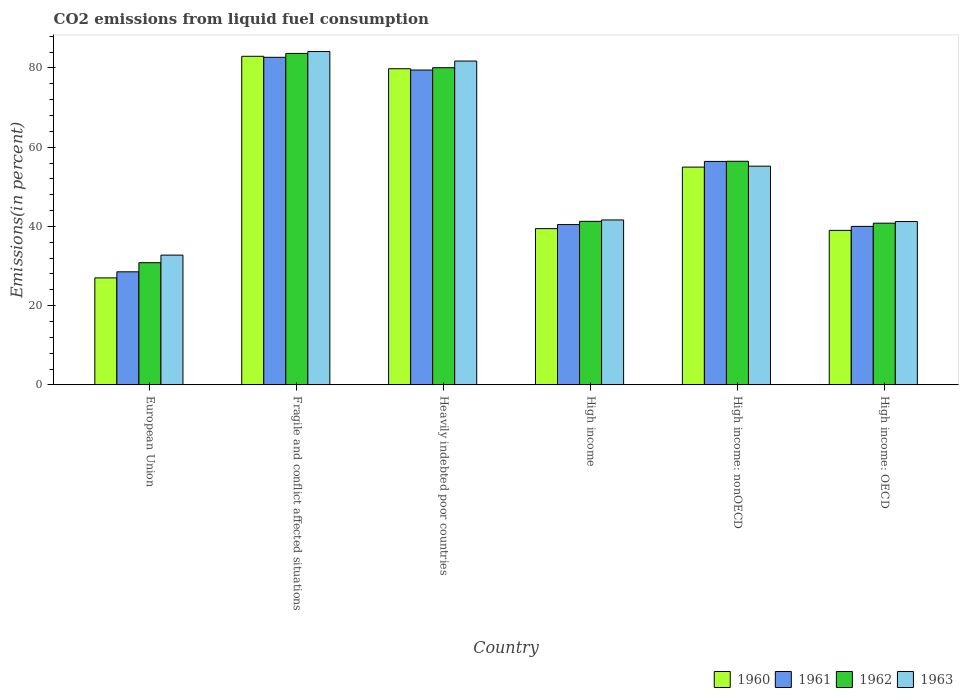How many groups of bars are there?
Give a very brief answer. 6. Are the number of bars per tick equal to the number of legend labels?
Keep it short and to the point. Yes. How many bars are there on the 1st tick from the left?
Provide a succinct answer. 4. How many bars are there on the 1st tick from the right?
Make the answer very short. 4. What is the label of the 1st group of bars from the left?
Ensure brevity in your answer.  European Union. What is the total CO2 emitted in 1961 in Fragile and conflict affected situations?
Provide a short and direct response. 82.67. Across all countries, what is the maximum total CO2 emitted in 1960?
Offer a terse response. 82.93. Across all countries, what is the minimum total CO2 emitted in 1961?
Offer a terse response. 28.54. In which country was the total CO2 emitted in 1961 maximum?
Provide a succinct answer. Fragile and conflict affected situations. In which country was the total CO2 emitted in 1960 minimum?
Offer a terse response. European Union. What is the total total CO2 emitted in 1960 in the graph?
Your answer should be very brief. 323.12. What is the difference between the total CO2 emitted in 1961 in European Union and that in Fragile and conflict affected situations?
Your answer should be very brief. -54.12. What is the difference between the total CO2 emitted in 1963 in Heavily indebted poor countries and the total CO2 emitted in 1961 in European Union?
Your answer should be compact. 53.19. What is the average total CO2 emitted in 1963 per country?
Keep it short and to the point. 56.11. What is the difference between the total CO2 emitted of/in 1962 and total CO2 emitted of/in 1961 in Fragile and conflict affected situations?
Your answer should be compact. 0.98. In how many countries, is the total CO2 emitted in 1963 greater than 16 %?
Provide a short and direct response. 6. What is the ratio of the total CO2 emitted in 1963 in Fragile and conflict affected situations to that in Heavily indebted poor countries?
Your response must be concise. 1.03. Is the total CO2 emitted in 1963 in High income: OECD less than that in High income: nonOECD?
Provide a succinct answer. Yes. Is the difference between the total CO2 emitted in 1962 in European Union and High income: OECD greater than the difference between the total CO2 emitted in 1961 in European Union and High income: OECD?
Make the answer very short. Yes. What is the difference between the highest and the second highest total CO2 emitted in 1961?
Ensure brevity in your answer.  -26.27. What is the difference between the highest and the lowest total CO2 emitted in 1960?
Keep it short and to the point. 55.92. Is the sum of the total CO2 emitted in 1962 in Heavily indebted poor countries and High income greater than the maximum total CO2 emitted in 1963 across all countries?
Provide a short and direct response. Yes. What does the 4th bar from the left in High income represents?
Provide a succinct answer. 1963. Is it the case that in every country, the sum of the total CO2 emitted in 1960 and total CO2 emitted in 1961 is greater than the total CO2 emitted in 1962?
Provide a short and direct response. Yes. Are the values on the major ticks of Y-axis written in scientific E-notation?
Provide a short and direct response. No. Does the graph contain any zero values?
Give a very brief answer. No. Does the graph contain grids?
Give a very brief answer. No. How are the legend labels stacked?
Ensure brevity in your answer.  Horizontal. What is the title of the graph?
Give a very brief answer. CO2 emissions from liquid fuel consumption. Does "1996" appear as one of the legend labels in the graph?
Give a very brief answer. No. What is the label or title of the Y-axis?
Provide a short and direct response. Emissions(in percent). What is the Emissions(in percent) in 1960 in European Union?
Your answer should be very brief. 27.01. What is the Emissions(in percent) in 1961 in European Union?
Provide a succinct answer. 28.54. What is the Emissions(in percent) of 1962 in European Union?
Your answer should be very brief. 30.84. What is the Emissions(in percent) of 1963 in European Union?
Your answer should be compact. 32.75. What is the Emissions(in percent) in 1960 in Fragile and conflict affected situations?
Your answer should be very brief. 82.93. What is the Emissions(in percent) of 1961 in Fragile and conflict affected situations?
Offer a very short reply. 82.67. What is the Emissions(in percent) in 1962 in Fragile and conflict affected situations?
Offer a terse response. 83.65. What is the Emissions(in percent) in 1963 in Fragile and conflict affected situations?
Your response must be concise. 84.13. What is the Emissions(in percent) in 1960 in Heavily indebted poor countries?
Your response must be concise. 79.79. What is the Emissions(in percent) of 1961 in Heavily indebted poor countries?
Your answer should be very brief. 79.46. What is the Emissions(in percent) in 1962 in Heavily indebted poor countries?
Ensure brevity in your answer.  80.05. What is the Emissions(in percent) in 1963 in Heavily indebted poor countries?
Your answer should be compact. 81.73. What is the Emissions(in percent) of 1960 in High income?
Your answer should be compact. 39.44. What is the Emissions(in percent) of 1961 in High income?
Your answer should be very brief. 40.46. What is the Emissions(in percent) in 1962 in High income?
Provide a short and direct response. 41.28. What is the Emissions(in percent) of 1963 in High income?
Your response must be concise. 41.63. What is the Emissions(in percent) of 1960 in High income: nonOECD?
Your answer should be very brief. 54.97. What is the Emissions(in percent) in 1961 in High income: nonOECD?
Make the answer very short. 56.4. What is the Emissions(in percent) in 1962 in High income: nonOECD?
Your response must be concise. 56.43. What is the Emissions(in percent) of 1963 in High income: nonOECD?
Your answer should be compact. 55.2. What is the Emissions(in percent) in 1960 in High income: OECD?
Make the answer very short. 39. What is the Emissions(in percent) in 1961 in High income: OECD?
Your answer should be very brief. 40. What is the Emissions(in percent) of 1962 in High income: OECD?
Offer a terse response. 40.81. What is the Emissions(in percent) in 1963 in High income: OECD?
Offer a very short reply. 41.23. Across all countries, what is the maximum Emissions(in percent) of 1960?
Your answer should be compact. 82.93. Across all countries, what is the maximum Emissions(in percent) in 1961?
Give a very brief answer. 82.67. Across all countries, what is the maximum Emissions(in percent) in 1962?
Give a very brief answer. 83.65. Across all countries, what is the maximum Emissions(in percent) in 1963?
Your answer should be very brief. 84.13. Across all countries, what is the minimum Emissions(in percent) of 1960?
Your answer should be compact. 27.01. Across all countries, what is the minimum Emissions(in percent) in 1961?
Provide a short and direct response. 28.54. Across all countries, what is the minimum Emissions(in percent) of 1962?
Ensure brevity in your answer.  30.84. Across all countries, what is the minimum Emissions(in percent) of 1963?
Offer a terse response. 32.75. What is the total Emissions(in percent) of 1960 in the graph?
Offer a very short reply. 323.12. What is the total Emissions(in percent) of 1961 in the graph?
Provide a short and direct response. 327.54. What is the total Emissions(in percent) of 1962 in the graph?
Give a very brief answer. 333.07. What is the total Emissions(in percent) of 1963 in the graph?
Provide a short and direct response. 336.67. What is the difference between the Emissions(in percent) in 1960 in European Union and that in Fragile and conflict affected situations?
Offer a terse response. -55.92. What is the difference between the Emissions(in percent) of 1961 in European Union and that in Fragile and conflict affected situations?
Ensure brevity in your answer.  -54.12. What is the difference between the Emissions(in percent) in 1962 in European Union and that in Fragile and conflict affected situations?
Keep it short and to the point. -52.81. What is the difference between the Emissions(in percent) in 1963 in European Union and that in Fragile and conflict affected situations?
Your response must be concise. -51.37. What is the difference between the Emissions(in percent) in 1960 in European Union and that in Heavily indebted poor countries?
Ensure brevity in your answer.  -52.78. What is the difference between the Emissions(in percent) in 1961 in European Union and that in Heavily indebted poor countries?
Offer a terse response. -50.91. What is the difference between the Emissions(in percent) in 1962 in European Union and that in Heavily indebted poor countries?
Your response must be concise. -49.21. What is the difference between the Emissions(in percent) of 1963 in European Union and that in Heavily indebted poor countries?
Provide a short and direct response. -48.98. What is the difference between the Emissions(in percent) in 1960 in European Union and that in High income?
Provide a succinct answer. -12.43. What is the difference between the Emissions(in percent) in 1961 in European Union and that in High income?
Provide a short and direct response. -11.92. What is the difference between the Emissions(in percent) in 1962 in European Union and that in High income?
Your answer should be compact. -10.44. What is the difference between the Emissions(in percent) in 1963 in European Union and that in High income?
Give a very brief answer. -8.87. What is the difference between the Emissions(in percent) in 1960 in European Union and that in High income: nonOECD?
Provide a succinct answer. -27.96. What is the difference between the Emissions(in percent) in 1961 in European Union and that in High income: nonOECD?
Give a very brief answer. -27.86. What is the difference between the Emissions(in percent) of 1962 in European Union and that in High income: nonOECD?
Keep it short and to the point. -25.59. What is the difference between the Emissions(in percent) of 1963 in European Union and that in High income: nonOECD?
Keep it short and to the point. -22.45. What is the difference between the Emissions(in percent) in 1960 in European Union and that in High income: OECD?
Ensure brevity in your answer.  -11.99. What is the difference between the Emissions(in percent) of 1961 in European Union and that in High income: OECD?
Offer a terse response. -11.46. What is the difference between the Emissions(in percent) in 1962 in European Union and that in High income: OECD?
Your answer should be compact. -9.97. What is the difference between the Emissions(in percent) of 1963 in European Union and that in High income: OECD?
Your answer should be compact. -8.47. What is the difference between the Emissions(in percent) in 1960 in Fragile and conflict affected situations and that in Heavily indebted poor countries?
Offer a very short reply. 3.14. What is the difference between the Emissions(in percent) in 1961 in Fragile and conflict affected situations and that in Heavily indebted poor countries?
Offer a very short reply. 3.21. What is the difference between the Emissions(in percent) of 1962 in Fragile and conflict affected situations and that in Heavily indebted poor countries?
Keep it short and to the point. 3.6. What is the difference between the Emissions(in percent) in 1963 in Fragile and conflict affected situations and that in Heavily indebted poor countries?
Your response must be concise. 2.4. What is the difference between the Emissions(in percent) in 1960 in Fragile and conflict affected situations and that in High income?
Your answer should be very brief. 43.49. What is the difference between the Emissions(in percent) in 1961 in Fragile and conflict affected situations and that in High income?
Offer a very short reply. 42.21. What is the difference between the Emissions(in percent) of 1962 in Fragile and conflict affected situations and that in High income?
Provide a short and direct response. 42.37. What is the difference between the Emissions(in percent) in 1963 in Fragile and conflict affected situations and that in High income?
Provide a succinct answer. 42.5. What is the difference between the Emissions(in percent) of 1960 in Fragile and conflict affected situations and that in High income: nonOECD?
Keep it short and to the point. 27.96. What is the difference between the Emissions(in percent) in 1961 in Fragile and conflict affected situations and that in High income: nonOECD?
Your answer should be very brief. 26.27. What is the difference between the Emissions(in percent) of 1962 in Fragile and conflict affected situations and that in High income: nonOECD?
Offer a terse response. 27.22. What is the difference between the Emissions(in percent) in 1963 in Fragile and conflict affected situations and that in High income: nonOECD?
Your response must be concise. 28.92. What is the difference between the Emissions(in percent) in 1960 in Fragile and conflict affected situations and that in High income: OECD?
Your response must be concise. 43.93. What is the difference between the Emissions(in percent) of 1961 in Fragile and conflict affected situations and that in High income: OECD?
Provide a short and direct response. 42.66. What is the difference between the Emissions(in percent) of 1962 in Fragile and conflict affected situations and that in High income: OECD?
Make the answer very short. 42.84. What is the difference between the Emissions(in percent) in 1963 in Fragile and conflict affected situations and that in High income: OECD?
Make the answer very short. 42.9. What is the difference between the Emissions(in percent) of 1960 in Heavily indebted poor countries and that in High income?
Your answer should be compact. 40.35. What is the difference between the Emissions(in percent) of 1961 in Heavily indebted poor countries and that in High income?
Provide a succinct answer. 38.99. What is the difference between the Emissions(in percent) in 1962 in Heavily indebted poor countries and that in High income?
Your answer should be very brief. 38.77. What is the difference between the Emissions(in percent) in 1963 in Heavily indebted poor countries and that in High income?
Make the answer very short. 40.1. What is the difference between the Emissions(in percent) of 1960 in Heavily indebted poor countries and that in High income: nonOECD?
Your answer should be compact. 24.82. What is the difference between the Emissions(in percent) in 1961 in Heavily indebted poor countries and that in High income: nonOECD?
Offer a terse response. 23.06. What is the difference between the Emissions(in percent) of 1962 in Heavily indebted poor countries and that in High income: nonOECD?
Give a very brief answer. 23.62. What is the difference between the Emissions(in percent) in 1963 in Heavily indebted poor countries and that in High income: nonOECD?
Give a very brief answer. 26.53. What is the difference between the Emissions(in percent) in 1960 in Heavily indebted poor countries and that in High income: OECD?
Provide a short and direct response. 40.79. What is the difference between the Emissions(in percent) of 1961 in Heavily indebted poor countries and that in High income: OECD?
Provide a short and direct response. 39.45. What is the difference between the Emissions(in percent) in 1962 in Heavily indebted poor countries and that in High income: OECD?
Your answer should be very brief. 39.24. What is the difference between the Emissions(in percent) in 1963 in Heavily indebted poor countries and that in High income: OECD?
Provide a succinct answer. 40.51. What is the difference between the Emissions(in percent) in 1960 in High income and that in High income: nonOECD?
Give a very brief answer. -15.53. What is the difference between the Emissions(in percent) in 1961 in High income and that in High income: nonOECD?
Your response must be concise. -15.94. What is the difference between the Emissions(in percent) in 1962 in High income and that in High income: nonOECD?
Keep it short and to the point. -15.16. What is the difference between the Emissions(in percent) in 1963 in High income and that in High income: nonOECD?
Offer a very short reply. -13.57. What is the difference between the Emissions(in percent) of 1960 in High income and that in High income: OECD?
Your answer should be very brief. 0.44. What is the difference between the Emissions(in percent) of 1961 in High income and that in High income: OECD?
Keep it short and to the point. 0.46. What is the difference between the Emissions(in percent) in 1962 in High income and that in High income: OECD?
Offer a very short reply. 0.47. What is the difference between the Emissions(in percent) in 1963 in High income and that in High income: OECD?
Keep it short and to the point. 0.4. What is the difference between the Emissions(in percent) of 1960 in High income: nonOECD and that in High income: OECD?
Your answer should be very brief. 15.97. What is the difference between the Emissions(in percent) of 1961 in High income: nonOECD and that in High income: OECD?
Give a very brief answer. 16.4. What is the difference between the Emissions(in percent) in 1962 in High income: nonOECD and that in High income: OECD?
Offer a terse response. 15.62. What is the difference between the Emissions(in percent) of 1963 in High income: nonOECD and that in High income: OECD?
Ensure brevity in your answer.  13.98. What is the difference between the Emissions(in percent) of 1960 in European Union and the Emissions(in percent) of 1961 in Fragile and conflict affected situations?
Ensure brevity in your answer.  -55.66. What is the difference between the Emissions(in percent) in 1960 in European Union and the Emissions(in percent) in 1962 in Fragile and conflict affected situations?
Your answer should be compact. -56.64. What is the difference between the Emissions(in percent) of 1960 in European Union and the Emissions(in percent) of 1963 in Fragile and conflict affected situations?
Provide a short and direct response. -57.12. What is the difference between the Emissions(in percent) of 1961 in European Union and the Emissions(in percent) of 1962 in Fragile and conflict affected situations?
Your answer should be very brief. -55.11. What is the difference between the Emissions(in percent) in 1961 in European Union and the Emissions(in percent) in 1963 in Fragile and conflict affected situations?
Ensure brevity in your answer.  -55.58. What is the difference between the Emissions(in percent) of 1962 in European Union and the Emissions(in percent) of 1963 in Fragile and conflict affected situations?
Your answer should be compact. -53.29. What is the difference between the Emissions(in percent) in 1960 in European Union and the Emissions(in percent) in 1961 in Heavily indebted poor countries?
Offer a very short reply. -52.45. What is the difference between the Emissions(in percent) of 1960 in European Union and the Emissions(in percent) of 1962 in Heavily indebted poor countries?
Give a very brief answer. -53.04. What is the difference between the Emissions(in percent) of 1960 in European Union and the Emissions(in percent) of 1963 in Heavily indebted poor countries?
Provide a succinct answer. -54.72. What is the difference between the Emissions(in percent) of 1961 in European Union and the Emissions(in percent) of 1962 in Heavily indebted poor countries?
Keep it short and to the point. -51.51. What is the difference between the Emissions(in percent) of 1961 in European Union and the Emissions(in percent) of 1963 in Heavily indebted poor countries?
Your answer should be compact. -53.19. What is the difference between the Emissions(in percent) of 1962 in European Union and the Emissions(in percent) of 1963 in Heavily indebted poor countries?
Your answer should be compact. -50.89. What is the difference between the Emissions(in percent) in 1960 in European Union and the Emissions(in percent) in 1961 in High income?
Ensure brevity in your answer.  -13.46. What is the difference between the Emissions(in percent) in 1960 in European Union and the Emissions(in percent) in 1962 in High income?
Provide a succinct answer. -14.27. What is the difference between the Emissions(in percent) of 1960 in European Union and the Emissions(in percent) of 1963 in High income?
Provide a succinct answer. -14.62. What is the difference between the Emissions(in percent) of 1961 in European Union and the Emissions(in percent) of 1962 in High income?
Make the answer very short. -12.73. What is the difference between the Emissions(in percent) of 1961 in European Union and the Emissions(in percent) of 1963 in High income?
Your answer should be compact. -13.08. What is the difference between the Emissions(in percent) in 1962 in European Union and the Emissions(in percent) in 1963 in High income?
Your response must be concise. -10.79. What is the difference between the Emissions(in percent) of 1960 in European Union and the Emissions(in percent) of 1961 in High income: nonOECD?
Give a very brief answer. -29.39. What is the difference between the Emissions(in percent) of 1960 in European Union and the Emissions(in percent) of 1962 in High income: nonOECD?
Keep it short and to the point. -29.43. What is the difference between the Emissions(in percent) in 1960 in European Union and the Emissions(in percent) in 1963 in High income: nonOECD?
Give a very brief answer. -28.19. What is the difference between the Emissions(in percent) in 1961 in European Union and the Emissions(in percent) in 1962 in High income: nonOECD?
Keep it short and to the point. -27.89. What is the difference between the Emissions(in percent) in 1961 in European Union and the Emissions(in percent) in 1963 in High income: nonOECD?
Your answer should be compact. -26.66. What is the difference between the Emissions(in percent) of 1962 in European Union and the Emissions(in percent) of 1963 in High income: nonOECD?
Give a very brief answer. -24.36. What is the difference between the Emissions(in percent) in 1960 in European Union and the Emissions(in percent) in 1961 in High income: OECD?
Keep it short and to the point. -13. What is the difference between the Emissions(in percent) of 1960 in European Union and the Emissions(in percent) of 1962 in High income: OECD?
Offer a very short reply. -13.81. What is the difference between the Emissions(in percent) of 1960 in European Union and the Emissions(in percent) of 1963 in High income: OECD?
Offer a very short reply. -14.22. What is the difference between the Emissions(in percent) of 1961 in European Union and the Emissions(in percent) of 1962 in High income: OECD?
Offer a terse response. -12.27. What is the difference between the Emissions(in percent) of 1961 in European Union and the Emissions(in percent) of 1963 in High income: OECD?
Your answer should be very brief. -12.68. What is the difference between the Emissions(in percent) of 1962 in European Union and the Emissions(in percent) of 1963 in High income: OECD?
Your answer should be very brief. -10.39. What is the difference between the Emissions(in percent) of 1960 in Fragile and conflict affected situations and the Emissions(in percent) of 1961 in Heavily indebted poor countries?
Provide a succinct answer. 3.47. What is the difference between the Emissions(in percent) of 1960 in Fragile and conflict affected situations and the Emissions(in percent) of 1962 in Heavily indebted poor countries?
Your answer should be very brief. 2.88. What is the difference between the Emissions(in percent) in 1960 in Fragile and conflict affected situations and the Emissions(in percent) in 1963 in Heavily indebted poor countries?
Your answer should be compact. 1.2. What is the difference between the Emissions(in percent) in 1961 in Fragile and conflict affected situations and the Emissions(in percent) in 1962 in Heavily indebted poor countries?
Ensure brevity in your answer.  2.62. What is the difference between the Emissions(in percent) in 1961 in Fragile and conflict affected situations and the Emissions(in percent) in 1963 in Heavily indebted poor countries?
Provide a succinct answer. 0.94. What is the difference between the Emissions(in percent) of 1962 in Fragile and conflict affected situations and the Emissions(in percent) of 1963 in Heavily indebted poor countries?
Offer a very short reply. 1.92. What is the difference between the Emissions(in percent) of 1960 in Fragile and conflict affected situations and the Emissions(in percent) of 1961 in High income?
Provide a short and direct response. 42.47. What is the difference between the Emissions(in percent) of 1960 in Fragile and conflict affected situations and the Emissions(in percent) of 1962 in High income?
Offer a very short reply. 41.65. What is the difference between the Emissions(in percent) in 1960 in Fragile and conflict affected situations and the Emissions(in percent) in 1963 in High income?
Offer a terse response. 41.3. What is the difference between the Emissions(in percent) in 1961 in Fragile and conflict affected situations and the Emissions(in percent) in 1962 in High income?
Give a very brief answer. 41.39. What is the difference between the Emissions(in percent) of 1961 in Fragile and conflict affected situations and the Emissions(in percent) of 1963 in High income?
Offer a terse response. 41.04. What is the difference between the Emissions(in percent) of 1962 in Fragile and conflict affected situations and the Emissions(in percent) of 1963 in High income?
Offer a terse response. 42.02. What is the difference between the Emissions(in percent) of 1960 in Fragile and conflict affected situations and the Emissions(in percent) of 1961 in High income: nonOECD?
Keep it short and to the point. 26.53. What is the difference between the Emissions(in percent) in 1960 in Fragile and conflict affected situations and the Emissions(in percent) in 1962 in High income: nonOECD?
Your response must be concise. 26.5. What is the difference between the Emissions(in percent) of 1960 in Fragile and conflict affected situations and the Emissions(in percent) of 1963 in High income: nonOECD?
Provide a short and direct response. 27.73. What is the difference between the Emissions(in percent) of 1961 in Fragile and conflict affected situations and the Emissions(in percent) of 1962 in High income: nonOECD?
Your answer should be very brief. 26.23. What is the difference between the Emissions(in percent) of 1961 in Fragile and conflict affected situations and the Emissions(in percent) of 1963 in High income: nonOECD?
Your response must be concise. 27.47. What is the difference between the Emissions(in percent) of 1962 in Fragile and conflict affected situations and the Emissions(in percent) of 1963 in High income: nonOECD?
Offer a terse response. 28.45. What is the difference between the Emissions(in percent) in 1960 in Fragile and conflict affected situations and the Emissions(in percent) in 1961 in High income: OECD?
Provide a short and direct response. 42.93. What is the difference between the Emissions(in percent) in 1960 in Fragile and conflict affected situations and the Emissions(in percent) in 1962 in High income: OECD?
Your answer should be very brief. 42.12. What is the difference between the Emissions(in percent) of 1960 in Fragile and conflict affected situations and the Emissions(in percent) of 1963 in High income: OECD?
Provide a short and direct response. 41.7. What is the difference between the Emissions(in percent) of 1961 in Fragile and conflict affected situations and the Emissions(in percent) of 1962 in High income: OECD?
Give a very brief answer. 41.86. What is the difference between the Emissions(in percent) of 1961 in Fragile and conflict affected situations and the Emissions(in percent) of 1963 in High income: OECD?
Your response must be concise. 41.44. What is the difference between the Emissions(in percent) of 1962 in Fragile and conflict affected situations and the Emissions(in percent) of 1963 in High income: OECD?
Keep it short and to the point. 42.43. What is the difference between the Emissions(in percent) in 1960 in Heavily indebted poor countries and the Emissions(in percent) in 1961 in High income?
Make the answer very short. 39.32. What is the difference between the Emissions(in percent) of 1960 in Heavily indebted poor countries and the Emissions(in percent) of 1962 in High income?
Give a very brief answer. 38.51. What is the difference between the Emissions(in percent) in 1960 in Heavily indebted poor countries and the Emissions(in percent) in 1963 in High income?
Keep it short and to the point. 38.16. What is the difference between the Emissions(in percent) of 1961 in Heavily indebted poor countries and the Emissions(in percent) of 1962 in High income?
Offer a very short reply. 38.18. What is the difference between the Emissions(in percent) of 1961 in Heavily indebted poor countries and the Emissions(in percent) of 1963 in High income?
Provide a short and direct response. 37.83. What is the difference between the Emissions(in percent) in 1962 in Heavily indebted poor countries and the Emissions(in percent) in 1963 in High income?
Provide a short and direct response. 38.42. What is the difference between the Emissions(in percent) of 1960 in Heavily indebted poor countries and the Emissions(in percent) of 1961 in High income: nonOECD?
Your response must be concise. 23.39. What is the difference between the Emissions(in percent) in 1960 in Heavily indebted poor countries and the Emissions(in percent) in 1962 in High income: nonOECD?
Your response must be concise. 23.35. What is the difference between the Emissions(in percent) in 1960 in Heavily indebted poor countries and the Emissions(in percent) in 1963 in High income: nonOECD?
Provide a succinct answer. 24.58. What is the difference between the Emissions(in percent) in 1961 in Heavily indebted poor countries and the Emissions(in percent) in 1962 in High income: nonOECD?
Make the answer very short. 23.02. What is the difference between the Emissions(in percent) of 1961 in Heavily indebted poor countries and the Emissions(in percent) of 1963 in High income: nonOECD?
Your answer should be very brief. 24.26. What is the difference between the Emissions(in percent) of 1962 in Heavily indebted poor countries and the Emissions(in percent) of 1963 in High income: nonOECD?
Give a very brief answer. 24.85. What is the difference between the Emissions(in percent) of 1960 in Heavily indebted poor countries and the Emissions(in percent) of 1961 in High income: OECD?
Ensure brevity in your answer.  39.78. What is the difference between the Emissions(in percent) in 1960 in Heavily indebted poor countries and the Emissions(in percent) in 1962 in High income: OECD?
Your answer should be compact. 38.97. What is the difference between the Emissions(in percent) in 1960 in Heavily indebted poor countries and the Emissions(in percent) in 1963 in High income: OECD?
Your answer should be compact. 38.56. What is the difference between the Emissions(in percent) in 1961 in Heavily indebted poor countries and the Emissions(in percent) in 1962 in High income: OECD?
Offer a terse response. 38.65. What is the difference between the Emissions(in percent) in 1961 in Heavily indebted poor countries and the Emissions(in percent) in 1963 in High income: OECD?
Give a very brief answer. 38.23. What is the difference between the Emissions(in percent) of 1962 in Heavily indebted poor countries and the Emissions(in percent) of 1963 in High income: OECD?
Offer a very short reply. 38.82. What is the difference between the Emissions(in percent) in 1960 in High income and the Emissions(in percent) in 1961 in High income: nonOECD?
Provide a succinct answer. -16.96. What is the difference between the Emissions(in percent) of 1960 in High income and the Emissions(in percent) of 1962 in High income: nonOECD?
Ensure brevity in your answer.  -17. What is the difference between the Emissions(in percent) of 1960 in High income and the Emissions(in percent) of 1963 in High income: nonOECD?
Provide a short and direct response. -15.77. What is the difference between the Emissions(in percent) of 1961 in High income and the Emissions(in percent) of 1962 in High income: nonOECD?
Offer a terse response. -15.97. What is the difference between the Emissions(in percent) in 1961 in High income and the Emissions(in percent) in 1963 in High income: nonOECD?
Provide a succinct answer. -14.74. What is the difference between the Emissions(in percent) of 1962 in High income and the Emissions(in percent) of 1963 in High income: nonOECD?
Ensure brevity in your answer.  -13.92. What is the difference between the Emissions(in percent) of 1960 in High income and the Emissions(in percent) of 1961 in High income: OECD?
Offer a terse response. -0.57. What is the difference between the Emissions(in percent) of 1960 in High income and the Emissions(in percent) of 1962 in High income: OECD?
Offer a terse response. -1.38. What is the difference between the Emissions(in percent) of 1960 in High income and the Emissions(in percent) of 1963 in High income: OECD?
Make the answer very short. -1.79. What is the difference between the Emissions(in percent) in 1961 in High income and the Emissions(in percent) in 1962 in High income: OECD?
Give a very brief answer. -0.35. What is the difference between the Emissions(in percent) of 1961 in High income and the Emissions(in percent) of 1963 in High income: OECD?
Your answer should be compact. -0.76. What is the difference between the Emissions(in percent) in 1962 in High income and the Emissions(in percent) in 1963 in High income: OECD?
Your answer should be very brief. 0.05. What is the difference between the Emissions(in percent) in 1960 in High income: nonOECD and the Emissions(in percent) in 1961 in High income: OECD?
Provide a succinct answer. 14.96. What is the difference between the Emissions(in percent) of 1960 in High income: nonOECD and the Emissions(in percent) of 1962 in High income: OECD?
Give a very brief answer. 14.15. What is the difference between the Emissions(in percent) of 1960 in High income: nonOECD and the Emissions(in percent) of 1963 in High income: OECD?
Offer a terse response. 13.74. What is the difference between the Emissions(in percent) in 1961 in High income: nonOECD and the Emissions(in percent) in 1962 in High income: OECD?
Give a very brief answer. 15.59. What is the difference between the Emissions(in percent) in 1961 in High income: nonOECD and the Emissions(in percent) in 1963 in High income: OECD?
Your answer should be compact. 15.17. What is the difference between the Emissions(in percent) in 1962 in High income: nonOECD and the Emissions(in percent) in 1963 in High income: OECD?
Offer a terse response. 15.21. What is the average Emissions(in percent) of 1960 per country?
Give a very brief answer. 53.85. What is the average Emissions(in percent) of 1961 per country?
Keep it short and to the point. 54.59. What is the average Emissions(in percent) in 1962 per country?
Make the answer very short. 55.51. What is the average Emissions(in percent) of 1963 per country?
Offer a terse response. 56.11. What is the difference between the Emissions(in percent) of 1960 and Emissions(in percent) of 1961 in European Union?
Offer a terse response. -1.54. What is the difference between the Emissions(in percent) in 1960 and Emissions(in percent) in 1962 in European Union?
Provide a short and direct response. -3.83. What is the difference between the Emissions(in percent) in 1960 and Emissions(in percent) in 1963 in European Union?
Your answer should be very brief. -5.75. What is the difference between the Emissions(in percent) in 1961 and Emissions(in percent) in 1962 in European Union?
Your answer should be compact. -2.3. What is the difference between the Emissions(in percent) in 1961 and Emissions(in percent) in 1963 in European Union?
Your response must be concise. -4.21. What is the difference between the Emissions(in percent) of 1962 and Emissions(in percent) of 1963 in European Union?
Offer a very short reply. -1.91. What is the difference between the Emissions(in percent) of 1960 and Emissions(in percent) of 1961 in Fragile and conflict affected situations?
Your response must be concise. 0.26. What is the difference between the Emissions(in percent) in 1960 and Emissions(in percent) in 1962 in Fragile and conflict affected situations?
Offer a terse response. -0.72. What is the difference between the Emissions(in percent) in 1960 and Emissions(in percent) in 1963 in Fragile and conflict affected situations?
Make the answer very short. -1.2. What is the difference between the Emissions(in percent) in 1961 and Emissions(in percent) in 1962 in Fragile and conflict affected situations?
Offer a terse response. -0.98. What is the difference between the Emissions(in percent) of 1961 and Emissions(in percent) of 1963 in Fragile and conflict affected situations?
Give a very brief answer. -1.46. What is the difference between the Emissions(in percent) in 1962 and Emissions(in percent) in 1963 in Fragile and conflict affected situations?
Make the answer very short. -0.47. What is the difference between the Emissions(in percent) of 1960 and Emissions(in percent) of 1961 in Heavily indebted poor countries?
Provide a succinct answer. 0.33. What is the difference between the Emissions(in percent) in 1960 and Emissions(in percent) in 1962 in Heavily indebted poor countries?
Your response must be concise. -0.26. What is the difference between the Emissions(in percent) in 1960 and Emissions(in percent) in 1963 in Heavily indebted poor countries?
Your answer should be compact. -1.95. What is the difference between the Emissions(in percent) of 1961 and Emissions(in percent) of 1962 in Heavily indebted poor countries?
Offer a very short reply. -0.59. What is the difference between the Emissions(in percent) of 1961 and Emissions(in percent) of 1963 in Heavily indebted poor countries?
Offer a terse response. -2.27. What is the difference between the Emissions(in percent) of 1962 and Emissions(in percent) of 1963 in Heavily indebted poor countries?
Offer a very short reply. -1.68. What is the difference between the Emissions(in percent) of 1960 and Emissions(in percent) of 1961 in High income?
Your answer should be compact. -1.03. What is the difference between the Emissions(in percent) in 1960 and Emissions(in percent) in 1962 in High income?
Provide a succinct answer. -1.84. What is the difference between the Emissions(in percent) of 1960 and Emissions(in percent) of 1963 in High income?
Offer a very short reply. -2.19. What is the difference between the Emissions(in percent) in 1961 and Emissions(in percent) in 1962 in High income?
Offer a very short reply. -0.81. What is the difference between the Emissions(in percent) of 1961 and Emissions(in percent) of 1963 in High income?
Make the answer very short. -1.16. What is the difference between the Emissions(in percent) of 1962 and Emissions(in percent) of 1963 in High income?
Provide a succinct answer. -0.35. What is the difference between the Emissions(in percent) in 1960 and Emissions(in percent) in 1961 in High income: nonOECD?
Your answer should be compact. -1.43. What is the difference between the Emissions(in percent) in 1960 and Emissions(in percent) in 1962 in High income: nonOECD?
Your answer should be compact. -1.47. What is the difference between the Emissions(in percent) of 1960 and Emissions(in percent) of 1963 in High income: nonOECD?
Offer a very short reply. -0.24. What is the difference between the Emissions(in percent) in 1961 and Emissions(in percent) in 1962 in High income: nonOECD?
Keep it short and to the point. -0.03. What is the difference between the Emissions(in percent) of 1961 and Emissions(in percent) of 1963 in High income: nonOECD?
Your answer should be compact. 1.2. What is the difference between the Emissions(in percent) of 1962 and Emissions(in percent) of 1963 in High income: nonOECD?
Keep it short and to the point. 1.23. What is the difference between the Emissions(in percent) in 1960 and Emissions(in percent) in 1961 in High income: OECD?
Provide a succinct answer. -1.01. What is the difference between the Emissions(in percent) in 1960 and Emissions(in percent) in 1962 in High income: OECD?
Offer a very short reply. -1.82. What is the difference between the Emissions(in percent) in 1960 and Emissions(in percent) in 1963 in High income: OECD?
Your answer should be compact. -2.23. What is the difference between the Emissions(in percent) of 1961 and Emissions(in percent) of 1962 in High income: OECD?
Make the answer very short. -0.81. What is the difference between the Emissions(in percent) of 1961 and Emissions(in percent) of 1963 in High income: OECD?
Keep it short and to the point. -1.22. What is the difference between the Emissions(in percent) of 1962 and Emissions(in percent) of 1963 in High income: OECD?
Your response must be concise. -0.41. What is the ratio of the Emissions(in percent) of 1960 in European Union to that in Fragile and conflict affected situations?
Provide a succinct answer. 0.33. What is the ratio of the Emissions(in percent) of 1961 in European Union to that in Fragile and conflict affected situations?
Keep it short and to the point. 0.35. What is the ratio of the Emissions(in percent) in 1962 in European Union to that in Fragile and conflict affected situations?
Offer a terse response. 0.37. What is the ratio of the Emissions(in percent) in 1963 in European Union to that in Fragile and conflict affected situations?
Offer a very short reply. 0.39. What is the ratio of the Emissions(in percent) in 1960 in European Union to that in Heavily indebted poor countries?
Your answer should be compact. 0.34. What is the ratio of the Emissions(in percent) of 1961 in European Union to that in Heavily indebted poor countries?
Your answer should be very brief. 0.36. What is the ratio of the Emissions(in percent) of 1962 in European Union to that in Heavily indebted poor countries?
Your response must be concise. 0.39. What is the ratio of the Emissions(in percent) of 1963 in European Union to that in Heavily indebted poor countries?
Provide a succinct answer. 0.4. What is the ratio of the Emissions(in percent) of 1960 in European Union to that in High income?
Your answer should be very brief. 0.68. What is the ratio of the Emissions(in percent) in 1961 in European Union to that in High income?
Make the answer very short. 0.71. What is the ratio of the Emissions(in percent) in 1962 in European Union to that in High income?
Offer a very short reply. 0.75. What is the ratio of the Emissions(in percent) of 1963 in European Union to that in High income?
Offer a very short reply. 0.79. What is the ratio of the Emissions(in percent) in 1960 in European Union to that in High income: nonOECD?
Provide a short and direct response. 0.49. What is the ratio of the Emissions(in percent) in 1961 in European Union to that in High income: nonOECD?
Offer a very short reply. 0.51. What is the ratio of the Emissions(in percent) in 1962 in European Union to that in High income: nonOECD?
Make the answer very short. 0.55. What is the ratio of the Emissions(in percent) of 1963 in European Union to that in High income: nonOECD?
Make the answer very short. 0.59. What is the ratio of the Emissions(in percent) of 1960 in European Union to that in High income: OECD?
Give a very brief answer. 0.69. What is the ratio of the Emissions(in percent) in 1961 in European Union to that in High income: OECD?
Offer a terse response. 0.71. What is the ratio of the Emissions(in percent) in 1962 in European Union to that in High income: OECD?
Your response must be concise. 0.76. What is the ratio of the Emissions(in percent) of 1963 in European Union to that in High income: OECD?
Provide a short and direct response. 0.79. What is the ratio of the Emissions(in percent) in 1960 in Fragile and conflict affected situations to that in Heavily indebted poor countries?
Provide a short and direct response. 1.04. What is the ratio of the Emissions(in percent) in 1961 in Fragile and conflict affected situations to that in Heavily indebted poor countries?
Ensure brevity in your answer.  1.04. What is the ratio of the Emissions(in percent) in 1962 in Fragile and conflict affected situations to that in Heavily indebted poor countries?
Offer a terse response. 1.04. What is the ratio of the Emissions(in percent) of 1963 in Fragile and conflict affected situations to that in Heavily indebted poor countries?
Provide a short and direct response. 1.03. What is the ratio of the Emissions(in percent) of 1960 in Fragile and conflict affected situations to that in High income?
Ensure brevity in your answer.  2.1. What is the ratio of the Emissions(in percent) in 1961 in Fragile and conflict affected situations to that in High income?
Offer a very short reply. 2.04. What is the ratio of the Emissions(in percent) in 1962 in Fragile and conflict affected situations to that in High income?
Offer a terse response. 2.03. What is the ratio of the Emissions(in percent) of 1963 in Fragile and conflict affected situations to that in High income?
Provide a succinct answer. 2.02. What is the ratio of the Emissions(in percent) in 1960 in Fragile and conflict affected situations to that in High income: nonOECD?
Your answer should be compact. 1.51. What is the ratio of the Emissions(in percent) of 1961 in Fragile and conflict affected situations to that in High income: nonOECD?
Offer a terse response. 1.47. What is the ratio of the Emissions(in percent) in 1962 in Fragile and conflict affected situations to that in High income: nonOECD?
Offer a very short reply. 1.48. What is the ratio of the Emissions(in percent) of 1963 in Fragile and conflict affected situations to that in High income: nonOECD?
Provide a short and direct response. 1.52. What is the ratio of the Emissions(in percent) in 1960 in Fragile and conflict affected situations to that in High income: OECD?
Provide a succinct answer. 2.13. What is the ratio of the Emissions(in percent) in 1961 in Fragile and conflict affected situations to that in High income: OECD?
Your response must be concise. 2.07. What is the ratio of the Emissions(in percent) in 1962 in Fragile and conflict affected situations to that in High income: OECD?
Provide a short and direct response. 2.05. What is the ratio of the Emissions(in percent) in 1963 in Fragile and conflict affected situations to that in High income: OECD?
Keep it short and to the point. 2.04. What is the ratio of the Emissions(in percent) in 1960 in Heavily indebted poor countries to that in High income?
Ensure brevity in your answer.  2.02. What is the ratio of the Emissions(in percent) of 1961 in Heavily indebted poor countries to that in High income?
Your answer should be compact. 1.96. What is the ratio of the Emissions(in percent) of 1962 in Heavily indebted poor countries to that in High income?
Offer a terse response. 1.94. What is the ratio of the Emissions(in percent) in 1963 in Heavily indebted poor countries to that in High income?
Ensure brevity in your answer.  1.96. What is the ratio of the Emissions(in percent) of 1960 in Heavily indebted poor countries to that in High income: nonOECD?
Provide a succinct answer. 1.45. What is the ratio of the Emissions(in percent) of 1961 in Heavily indebted poor countries to that in High income: nonOECD?
Your response must be concise. 1.41. What is the ratio of the Emissions(in percent) in 1962 in Heavily indebted poor countries to that in High income: nonOECD?
Offer a very short reply. 1.42. What is the ratio of the Emissions(in percent) in 1963 in Heavily indebted poor countries to that in High income: nonOECD?
Make the answer very short. 1.48. What is the ratio of the Emissions(in percent) in 1960 in Heavily indebted poor countries to that in High income: OECD?
Your response must be concise. 2.05. What is the ratio of the Emissions(in percent) of 1961 in Heavily indebted poor countries to that in High income: OECD?
Ensure brevity in your answer.  1.99. What is the ratio of the Emissions(in percent) of 1962 in Heavily indebted poor countries to that in High income: OECD?
Your answer should be compact. 1.96. What is the ratio of the Emissions(in percent) in 1963 in Heavily indebted poor countries to that in High income: OECD?
Your answer should be very brief. 1.98. What is the ratio of the Emissions(in percent) in 1960 in High income to that in High income: nonOECD?
Your answer should be compact. 0.72. What is the ratio of the Emissions(in percent) in 1961 in High income to that in High income: nonOECD?
Your answer should be very brief. 0.72. What is the ratio of the Emissions(in percent) of 1962 in High income to that in High income: nonOECD?
Your response must be concise. 0.73. What is the ratio of the Emissions(in percent) in 1963 in High income to that in High income: nonOECD?
Your answer should be compact. 0.75. What is the ratio of the Emissions(in percent) of 1960 in High income to that in High income: OECD?
Make the answer very short. 1.01. What is the ratio of the Emissions(in percent) of 1961 in High income to that in High income: OECD?
Your answer should be very brief. 1.01. What is the ratio of the Emissions(in percent) of 1962 in High income to that in High income: OECD?
Your answer should be very brief. 1.01. What is the ratio of the Emissions(in percent) in 1963 in High income to that in High income: OECD?
Give a very brief answer. 1.01. What is the ratio of the Emissions(in percent) in 1960 in High income: nonOECD to that in High income: OECD?
Provide a short and direct response. 1.41. What is the ratio of the Emissions(in percent) of 1961 in High income: nonOECD to that in High income: OECD?
Make the answer very short. 1.41. What is the ratio of the Emissions(in percent) of 1962 in High income: nonOECD to that in High income: OECD?
Keep it short and to the point. 1.38. What is the ratio of the Emissions(in percent) of 1963 in High income: nonOECD to that in High income: OECD?
Provide a short and direct response. 1.34. What is the difference between the highest and the second highest Emissions(in percent) of 1960?
Give a very brief answer. 3.14. What is the difference between the highest and the second highest Emissions(in percent) in 1961?
Offer a very short reply. 3.21. What is the difference between the highest and the second highest Emissions(in percent) in 1962?
Make the answer very short. 3.6. What is the difference between the highest and the second highest Emissions(in percent) of 1963?
Your answer should be very brief. 2.4. What is the difference between the highest and the lowest Emissions(in percent) of 1960?
Provide a short and direct response. 55.92. What is the difference between the highest and the lowest Emissions(in percent) in 1961?
Provide a succinct answer. 54.12. What is the difference between the highest and the lowest Emissions(in percent) in 1962?
Ensure brevity in your answer.  52.81. What is the difference between the highest and the lowest Emissions(in percent) of 1963?
Make the answer very short. 51.37. 